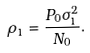Convert formula to latex. <formula><loc_0><loc_0><loc_500><loc_500>\rho _ { 1 } = \frac { P _ { 0 } \sigma _ { 1 } ^ { 2 } } { N _ { 0 } } .</formula> 